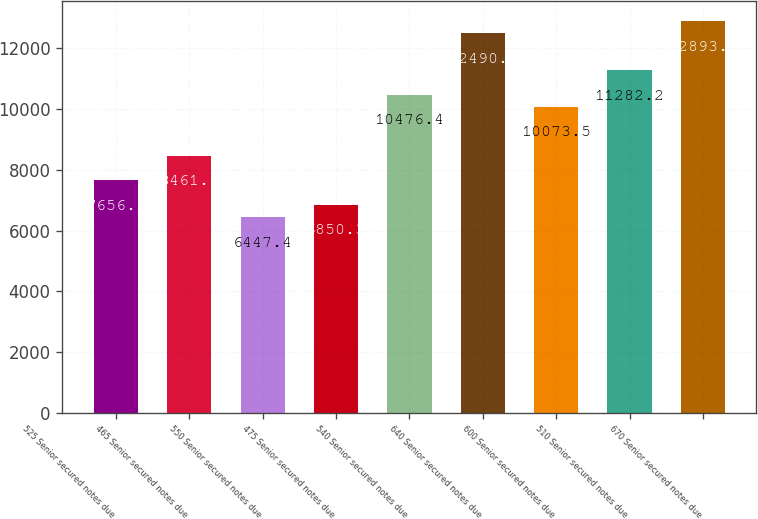Convert chart to OTSL. <chart><loc_0><loc_0><loc_500><loc_500><bar_chart><fcel>525 Senior secured notes due<fcel>465 Senior secured notes due<fcel>550 Senior secured notes due<fcel>475 Senior secured notes due<fcel>540 Senior secured notes due<fcel>640 Senior secured notes due<fcel>600 Senior secured notes due<fcel>510 Senior secured notes due<fcel>670 Senior secured notes due<nl><fcel>7656.1<fcel>8461.9<fcel>6447.4<fcel>6850.3<fcel>10476.4<fcel>12490.9<fcel>10073.5<fcel>11282.2<fcel>12893.8<nl></chart> 